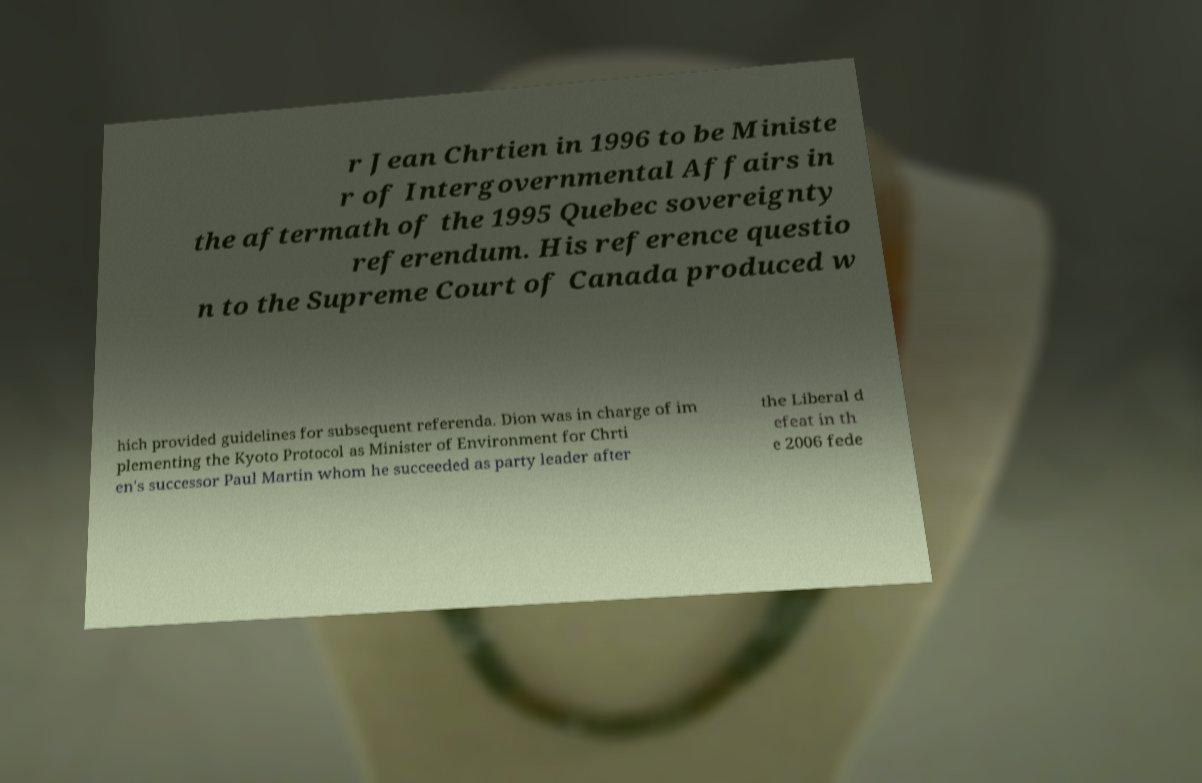Can you accurately transcribe the text from the provided image for me? r Jean Chrtien in 1996 to be Ministe r of Intergovernmental Affairs in the aftermath of the 1995 Quebec sovereignty referendum. His reference questio n to the Supreme Court of Canada produced w hich provided guidelines for subsequent referenda. Dion was in charge of im plementing the Kyoto Protocol as Minister of Environment for Chrti en's successor Paul Martin whom he succeeded as party leader after the Liberal d efeat in th e 2006 fede 